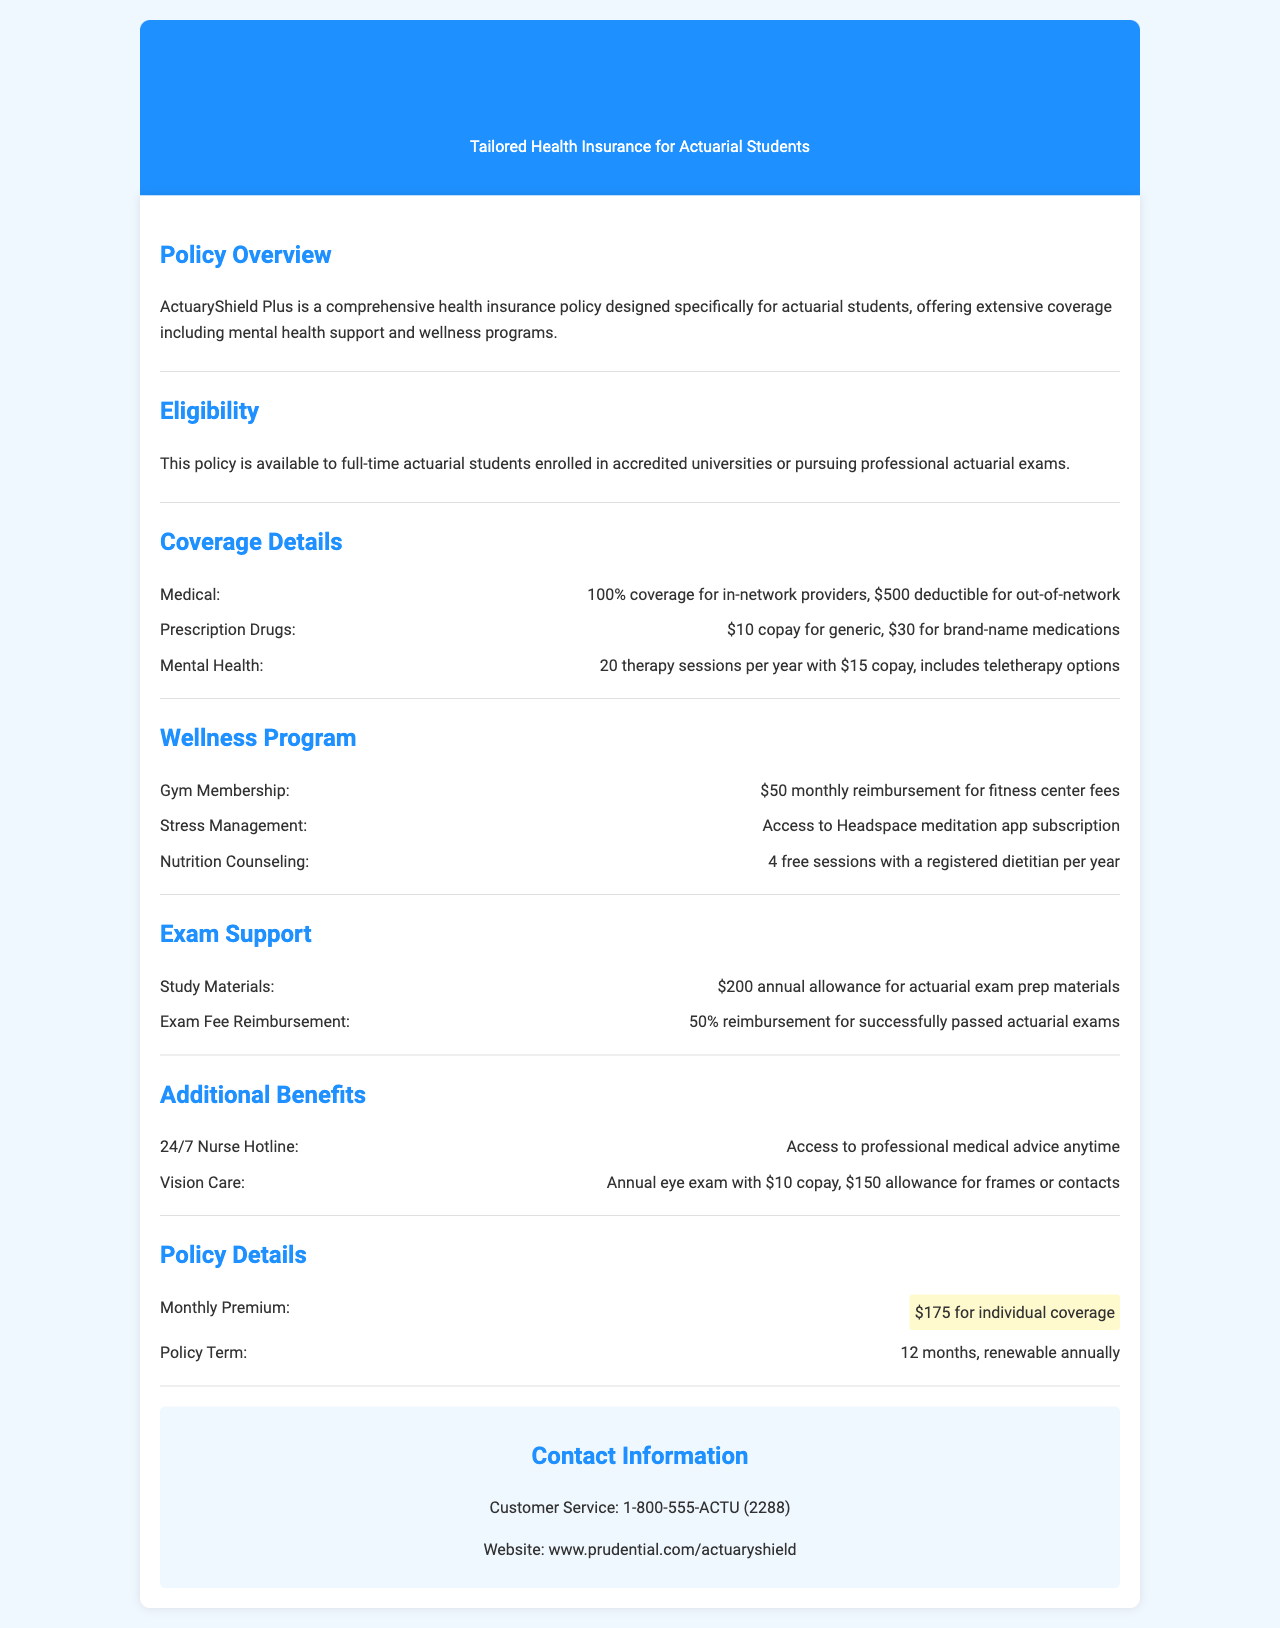what is the monthly premium for individual coverage? The monthly premium for individual coverage is stated in the policy details section of the document.
Answer: $175 how many therapy sessions are covered per year for mental health? The coverage details specify the number of therapy sessions included for mental health.
Answer: 20 sessions what is the reimbursement amount for gym membership? The wellness program section lists the amount for gym membership reimbursement.
Answer: $50 how many free nutrition counseling sessions are provided per year? The document mentions the number of free sessions with a registered dietitian under the wellness program.
Answer: 4 sessions what percentage of exam fees is reimbursed for successfully passed actuarial exams? The exam support section indicates the reimbursement percentage for exam fees.
Answer: 50% what type of meditation app subscription is provided under stress management? The wellness program details which meditation app is included for stress management.
Answer: Headspace is the policy renewable? The policy details mention whether the policy can be renewed or not.
Answer: Yes what is the eligibility criteria for the policy? The eligibility section outlines the criteria for who can enroll in the policy.
Answer: Full-time actuarial students what type of care does the vision care benefit include? The additional benefits section describes what the vision care benefit covers.
Answer: Annual eye exam 